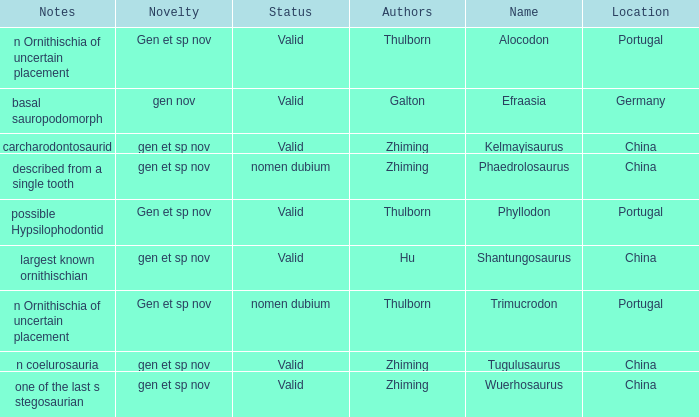What is the Novelty of the dinosaur, whose naming Author was Galton? Gen nov. 